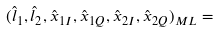Convert formula to latex. <formula><loc_0><loc_0><loc_500><loc_500>( { \hat { l } } _ { 1 } , { \hat { l } } _ { 2 } , \hat { x } _ { 1 I } , \hat { x } _ { 1 Q } , \hat { x } _ { 2 I } , \hat { x } _ { 2 Q } ) _ { M L } =</formula> 